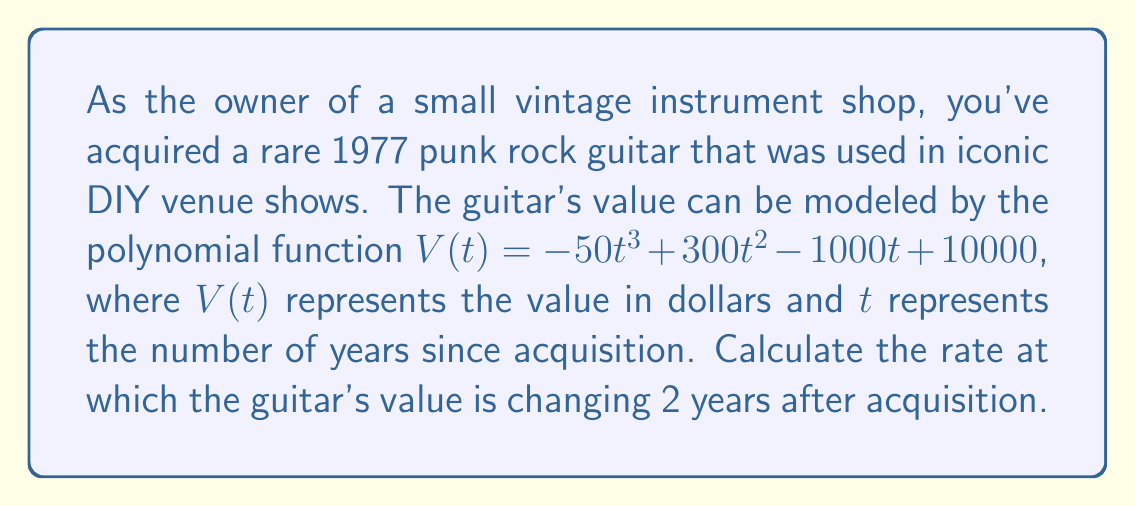Can you answer this question? To find the rate at which the guitar's value is changing 2 years after acquisition, we need to calculate the derivative of the given polynomial function and evaluate it at $t = 2$.

1. Given polynomial function: 
   $V(t) = -50t^3 + 300t^2 - 1000t + 10000$

2. Calculate the derivative $V'(t)$:
   $V'(t) = \frac{d}{dt}(-50t^3 + 300t^2 - 1000t + 10000)$
   $V'(t) = -150t^2 + 600t - 1000$

3. Evaluate $V'(t)$ at $t = 2$:
   $V'(2) = -150(2)^2 + 600(2) - 1000$
   $V'(2) = -150(4) + 1200 - 1000$
   $V'(2) = -600 + 1200 - 1000$
   $V'(2) = -400$

The negative value indicates that the guitar's value is decreasing at this point in time.
Answer: The rate at which the guitar's value is changing 2 years after acquisition is $-400$ dollars per year. 